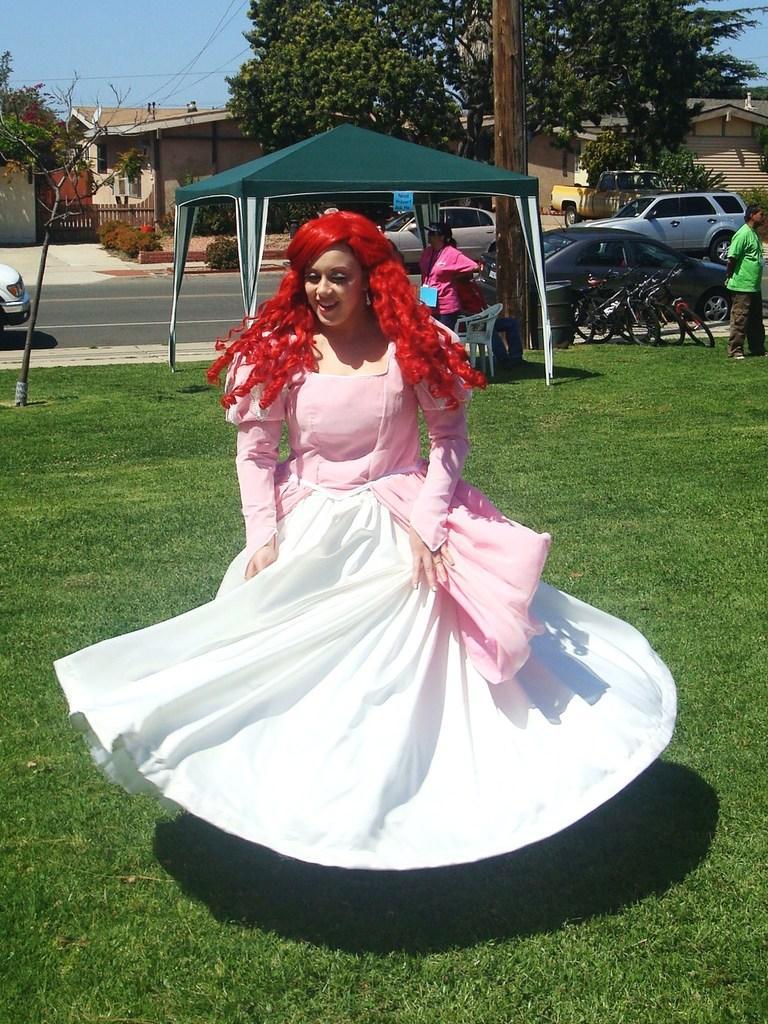Describe this image in one or two sentences. In this picture there are people and we can see grass, tent, vehicles, road, pole and plant. In the background of the image we can see houses, trees, plants, fence and sky. 